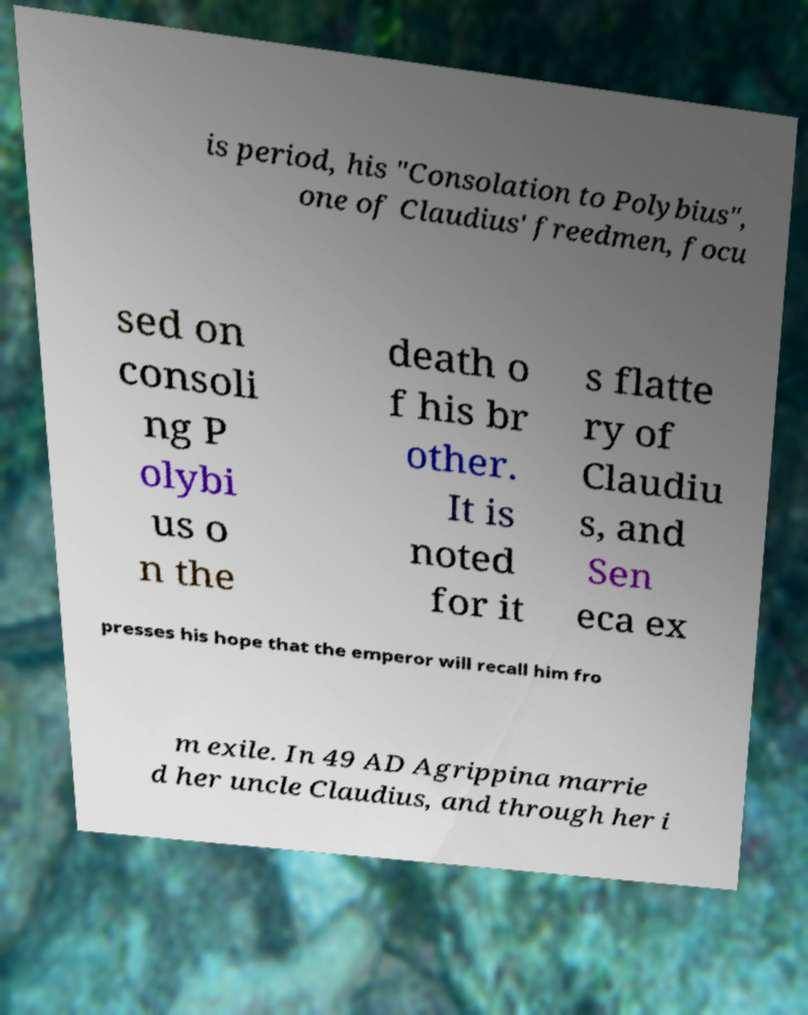Can you accurately transcribe the text from the provided image for me? is period, his "Consolation to Polybius", one of Claudius' freedmen, focu sed on consoli ng P olybi us o n the death o f his br other. It is noted for it s flatte ry of Claudiu s, and Sen eca ex presses his hope that the emperor will recall him fro m exile. In 49 AD Agrippina marrie d her uncle Claudius, and through her i 